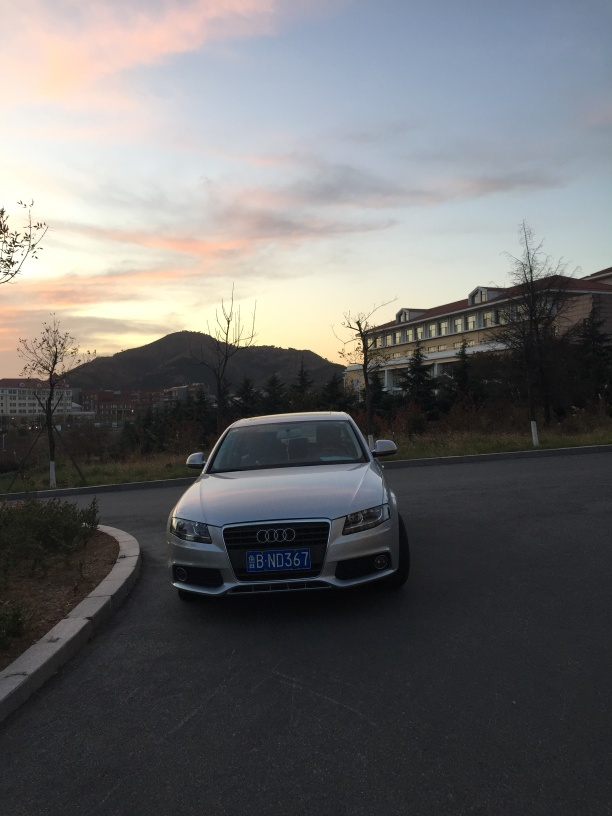What is the overall clarity of the image? The image is somewhat clear but lacks sharpness, possibly due to the lighting conditions at dusk. The details of the car and the buildings are visible; however, the image could be enhanced by adjusting the focus and exposure to improve the clarity. 